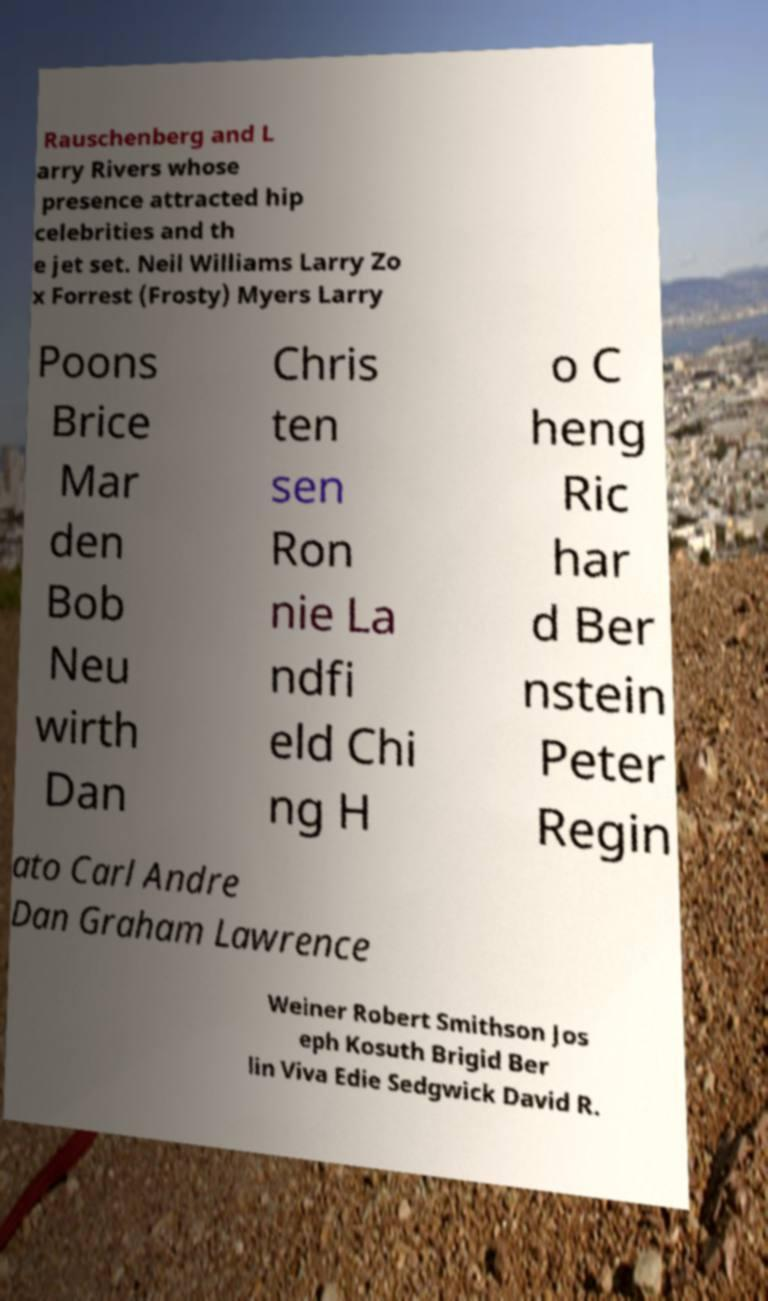Could you assist in decoding the text presented in this image and type it out clearly? Rauschenberg and L arry Rivers whose presence attracted hip celebrities and th e jet set. Neil Williams Larry Zo x Forrest (Frosty) Myers Larry Poons Brice Mar den Bob Neu wirth Dan Chris ten sen Ron nie La ndfi eld Chi ng H o C heng Ric har d Ber nstein Peter Regin ato Carl Andre Dan Graham Lawrence Weiner Robert Smithson Jos eph Kosuth Brigid Ber lin Viva Edie Sedgwick David R. 